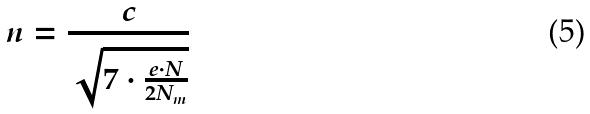Convert formula to latex. <formula><loc_0><loc_0><loc_500><loc_500>n = \frac { c } { \sqrt { 7 \cdot \frac { e \cdot N } { 2 N _ { m } } } }</formula> 